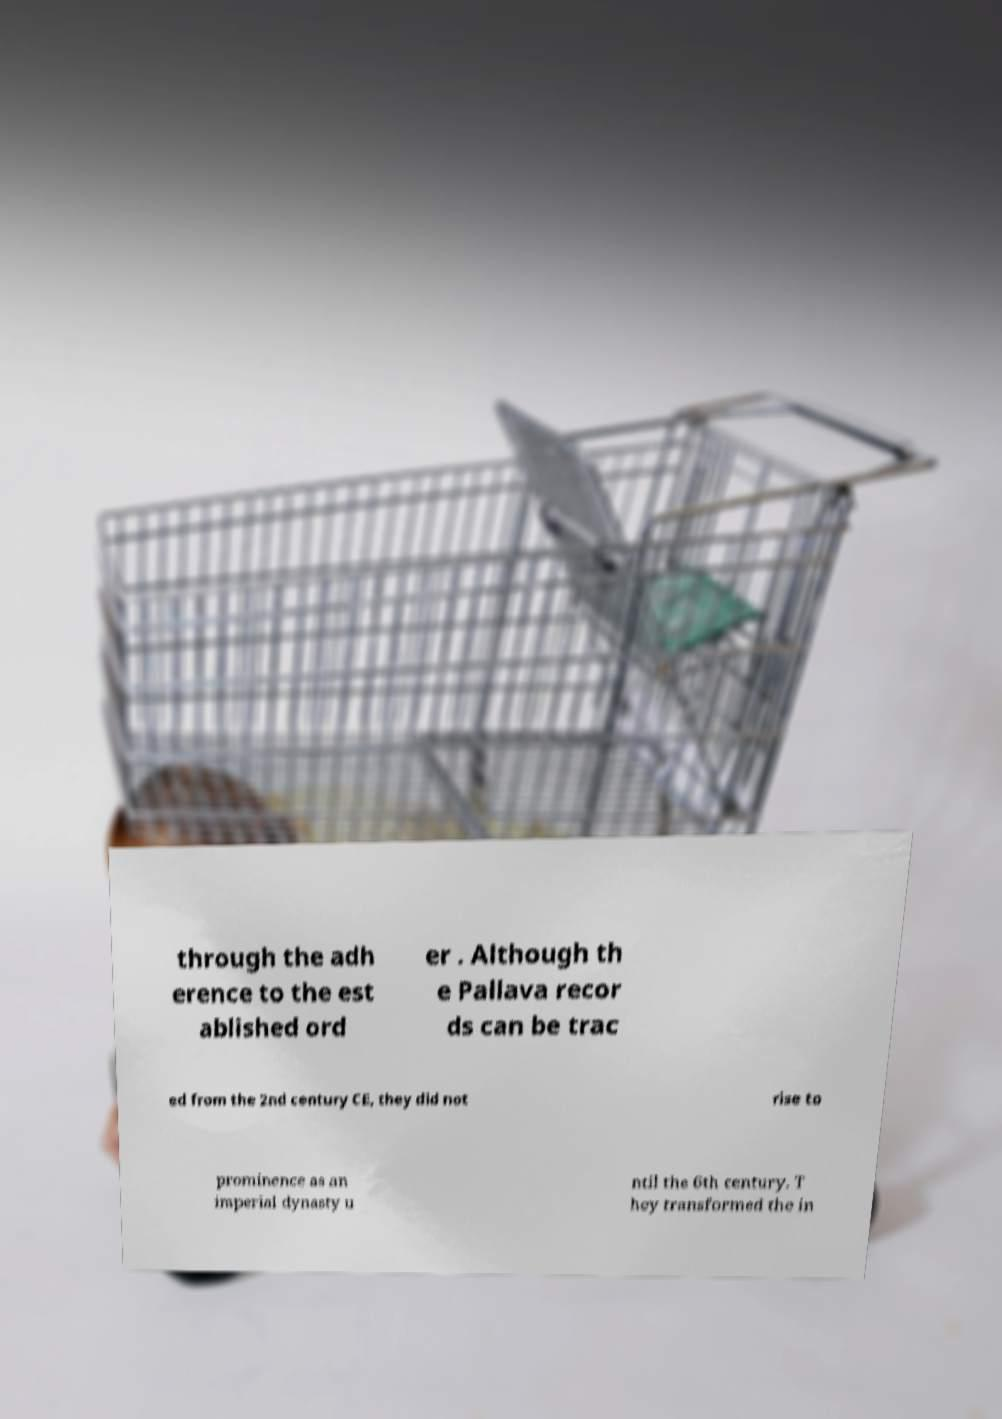Could you extract and type out the text from this image? through the adh erence to the est ablished ord er . Although th e Pallava recor ds can be trac ed from the 2nd century CE, they did not rise to prominence as an imperial dynasty u ntil the 6th century. T hey transformed the in 